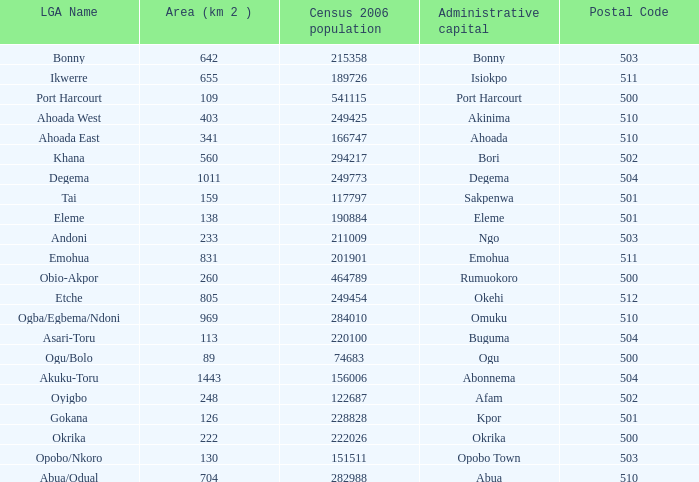What is the 2006 census population when the area is 159? 1.0. 